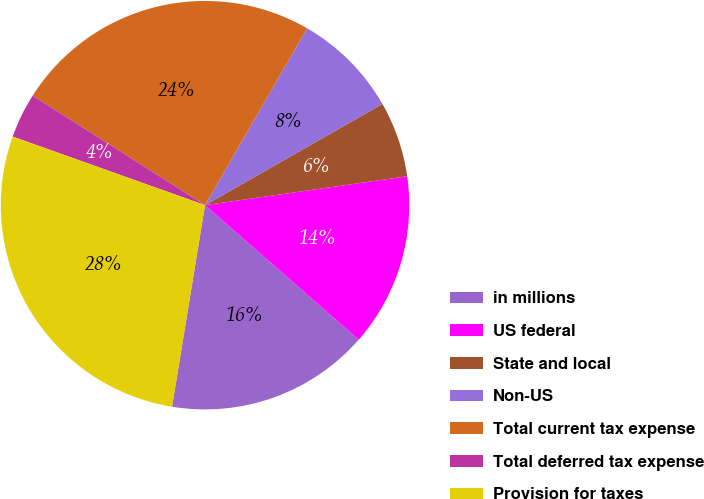<chart> <loc_0><loc_0><loc_500><loc_500><pie_chart><fcel>in millions<fcel>US federal<fcel>State and local<fcel>Non-US<fcel>Total current tax expense<fcel>Total deferred tax expense<fcel>Provision for taxes<nl><fcel>16.14%<fcel>13.71%<fcel>5.99%<fcel>8.42%<fcel>24.32%<fcel>3.56%<fcel>27.87%<nl></chart> 